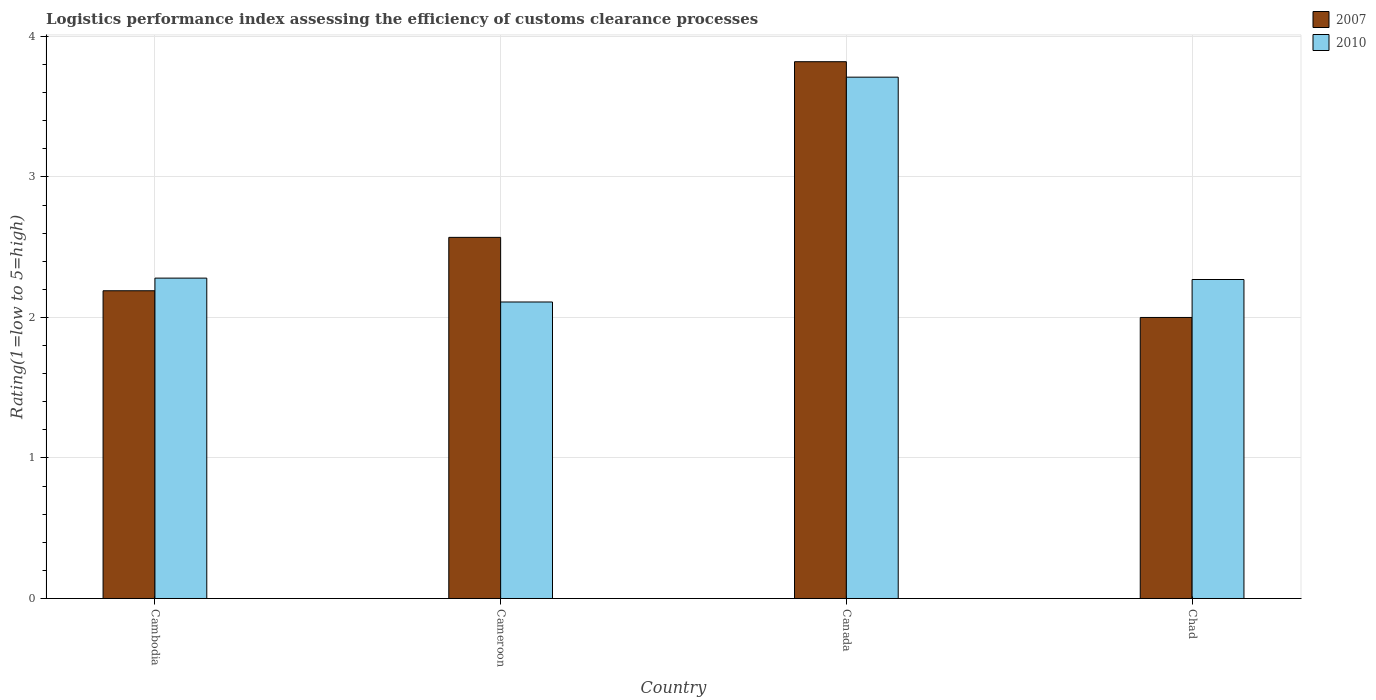How many different coloured bars are there?
Give a very brief answer. 2. Are the number of bars per tick equal to the number of legend labels?
Make the answer very short. Yes. How many bars are there on the 3rd tick from the left?
Offer a very short reply. 2. What is the Logistic performance index in 2007 in Cameroon?
Your response must be concise. 2.57. Across all countries, what is the maximum Logistic performance index in 2010?
Keep it short and to the point. 3.71. Across all countries, what is the minimum Logistic performance index in 2010?
Your response must be concise. 2.11. In which country was the Logistic performance index in 2010 maximum?
Your answer should be compact. Canada. In which country was the Logistic performance index in 2010 minimum?
Provide a short and direct response. Cameroon. What is the total Logistic performance index in 2007 in the graph?
Keep it short and to the point. 10.58. What is the difference between the Logistic performance index in 2007 in Cameroon and that in Chad?
Your response must be concise. 0.57. What is the difference between the Logistic performance index in 2007 in Cameroon and the Logistic performance index in 2010 in Chad?
Make the answer very short. 0.3. What is the average Logistic performance index in 2007 per country?
Provide a short and direct response. 2.65. What is the difference between the Logistic performance index of/in 2007 and Logistic performance index of/in 2010 in Chad?
Your response must be concise. -0.27. What is the ratio of the Logistic performance index in 2010 in Cambodia to that in Canada?
Offer a very short reply. 0.61. Is the Logistic performance index in 2007 in Cambodia less than that in Chad?
Provide a succinct answer. No. Is the difference between the Logistic performance index in 2007 in Canada and Chad greater than the difference between the Logistic performance index in 2010 in Canada and Chad?
Make the answer very short. Yes. What is the difference between the highest and the second highest Logistic performance index in 2010?
Your answer should be very brief. -0.01. What is the difference between the highest and the lowest Logistic performance index in 2007?
Provide a succinct answer. 1.82. How many bars are there?
Give a very brief answer. 8. Are all the bars in the graph horizontal?
Ensure brevity in your answer.  No. What is the difference between two consecutive major ticks on the Y-axis?
Offer a very short reply. 1. Does the graph contain any zero values?
Your answer should be compact. No. Does the graph contain grids?
Your response must be concise. Yes. How many legend labels are there?
Offer a terse response. 2. How are the legend labels stacked?
Ensure brevity in your answer.  Vertical. What is the title of the graph?
Your answer should be very brief. Logistics performance index assessing the efficiency of customs clearance processes. What is the label or title of the Y-axis?
Your answer should be very brief. Rating(1=low to 5=high). What is the Rating(1=low to 5=high) in 2007 in Cambodia?
Make the answer very short. 2.19. What is the Rating(1=low to 5=high) of 2010 in Cambodia?
Ensure brevity in your answer.  2.28. What is the Rating(1=low to 5=high) of 2007 in Cameroon?
Give a very brief answer. 2.57. What is the Rating(1=low to 5=high) of 2010 in Cameroon?
Offer a very short reply. 2.11. What is the Rating(1=low to 5=high) of 2007 in Canada?
Your response must be concise. 3.82. What is the Rating(1=low to 5=high) of 2010 in Canada?
Ensure brevity in your answer.  3.71. What is the Rating(1=low to 5=high) in 2007 in Chad?
Ensure brevity in your answer.  2. What is the Rating(1=low to 5=high) of 2010 in Chad?
Offer a terse response. 2.27. Across all countries, what is the maximum Rating(1=low to 5=high) in 2007?
Provide a succinct answer. 3.82. Across all countries, what is the maximum Rating(1=low to 5=high) of 2010?
Your answer should be very brief. 3.71. Across all countries, what is the minimum Rating(1=low to 5=high) of 2010?
Your answer should be compact. 2.11. What is the total Rating(1=low to 5=high) of 2007 in the graph?
Make the answer very short. 10.58. What is the total Rating(1=low to 5=high) of 2010 in the graph?
Your answer should be very brief. 10.37. What is the difference between the Rating(1=low to 5=high) in 2007 in Cambodia and that in Cameroon?
Your answer should be compact. -0.38. What is the difference between the Rating(1=low to 5=high) in 2010 in Cambodia and that in Cameroon?
Provide a succinct answer. 0.17. What is the difference between the Rating(1=low to 5=high) in 2007 in Cambodia and that in Canada?
Give a very brief answer. -1.63. What is the difference between the Rating(1=low to 5=high) in 2010 in Cambodia and that in Canada?
Provide a short and direct response. -1.43. What is the difference between the Rating(1=low to 5=high) of 2007 in Cambodia and that in Chad?
Make the answer very short. 0.19. What is the difference between the Rating(1=low to 5=high) in 2010 in Cambodia and that in Chad?
Your answer should be compact. 0.01. What is the difference between the Rating(1=low to 5=high) in 2007 in Cameroon and that in Canada?
Provide a succinct answer. -1.25. What is the difference between the Rating(1=low to 5=high) in 2007 in Cameroon and that in Chad?
Offer a terse response. 0.57. What is the difference between the Rating(1=low to 5=high) in 2010 in Cameroon and that in Chad?
Your answer should be very brief. -0.16. What is the difference between the Rating(1=low to 5=high) of 2007 in Canada and that in Chad?
Provide a succinct answer. 1.82. What is the difference between the Rating(1=low to 5=high) of 2010 in Canada and that in Chad?
Make the answer very short. 1.44. What is the difference between the Rating(1=low to 5=high) in 2007 in Cambodia and the Rating(1=low to 5=high) in 2010 in Canada?
Your answer should be very brief. -1.52. What is the difference between the Rating(1=low to 5=high) of 2007 in Cambodia and the Rating(1=low to 5=high) of 2010 in Chad?
Make the answer very short. -0.08. What is the difference between the Rating(1=low to 5=high) in 2007 in Cameroon and the Rating(1=low to 5=high) in 2010 in Canada?
Ensure brevity in your answer.  -1.14. What is the difference between the Rating(1=low to 5=high) of 2007 in Cameroon and the Rating(1=low to 5=high) of 2010 in Chad?
Make the answer very short. 0.3. What is the difference between the Rating(1=low to 5=high) in 2007 in Canada and the Rating(1=low to 5=high) in 2010 in Chad?
Keep it short and to the point. 1.55. What is the average Rating(1=low to 5=high) of 2007 per country?
Offer a terse response. 2.65. What is the average Rating(1=low to 5=high) in 2010 per country?
Your answer should be very brief. 2.59. What is the difference between the Rating(1=low to 5=high) in 2007 and Rating(1=low to 5=high) in 2010 in Cambodia?
Give a very brief answer. -0.09. What is the difference between the Rating(1=low to 5=high) of 2007 and Rating(1=low to 5=high) of 2010 in Cameroon?
Keep it short and to the point. 0.46. What is the difference between the Rating(1=low to 5=high) of 2007 and Rating(1=low to 5=high) of 2010 in Canada?
Your answer should be compact. 0.11. What is the difference between the Rating(1=low to 5=high) in 2007 and Rating(1=low to 5=high) in 2010 in Chad?
Your answer should be compact. -0.27. What is the ratio of the Rating(1=low to 5=high) of 2007 in Cambodia to that in Cameroon?
Make the answer very short. 0.85. What is the ratio of the Rating(1=low to 5=high) in 2010 in Cambodia to that in Cameroon?
Provide a succinct answer. 1.08. What is the ratio of the Rating(1=low to 5=high) in 2007 in Cambodia to that in Canada?
Keep it short and to the point. 0.57. What is the ratio of the Rating(1=low to 5=high) of 2010 in Cambodia to that in Canada?
Offer a terse response. 0.61. What is the ratio of the Rating(1=low to 5=high) in 2007 in Cambodia to that in Chad?
Your response must be concise. 1.09. What is the ratio of the Rating(1=low to 5=high) in 2010 in Cambodia to that in Chad?
Ensure brevity in your answer.  1. What is the ratio of the Rating(1=low to 5=high) of 2007 in Cameroon to that in Canada?
Offer a terse response. 0.67. What is the ratio of the Rating(1=low to 5=high) of 2010 in Cameroon to that in Canada?
Give a very brief answer. 0.57. What is the ratio of the Rating(1=low to 5=high) in 2007 in Cameroon to that in Chad?
Provide a short and direct response. 1.28. What is the ratio of the Rating(1=low to 5=high) of 2010 in Cameroon to that in Chad?
Offer a very short reply. 0.93. What is the ratio of the Rating(1=low to 5=high) in 2007 in Canada to that in Chad?
Offer a very short reply. 1.91. What is the ratio of the Rating(1=low to 5=high) in 2010 in Canada to that in Chad?
Offer a terse response. 1.63. What is the difference between the highest and the second highest Rating(1=low to 5=high) in 2007?
Offer a very short reply. 1.25. What is the difference between the highest and the second highest Rating(1=low to 5=high) in 2010?
Your answer should be compact. 1.43. What is the difference between the highest and the lowest Rating(1=low to 5=high) in 2007?
Ensure brevity in your answer.  1.82. What is the difference between the highest and the lowest Rating(1=low to 5=high) in 2010?
Your response must be concise. 1.6. 